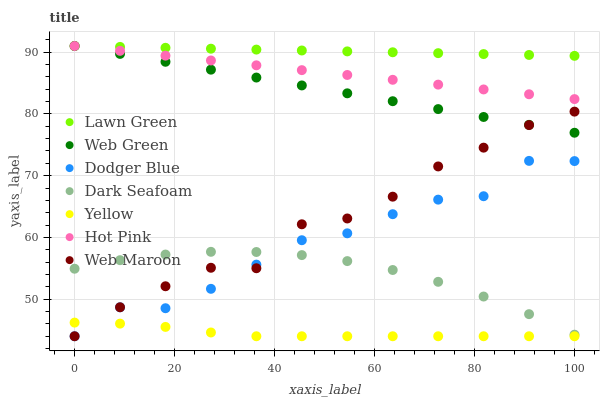Does Yellow have the minimum area under the curve?
Answer yes or no. Yes. Does Lawn Green have the maximum area under the curve?
Answer yes or no. Yes. Does Hot Pink have the minimum area under the curve?
Answer yes or no. No. Does Hot Pink have the maximum area under the curve?
Answer yes or no. No. Is Lawn Green the smoothest?
Answer yes or no. Yes. Is Dodger Blue the roughest?
Answer yes or no. Yes. Is Hot Pink the smoothest?
Answer yes or no. No. Is Hot Pink the roughest?
Answer yes or no. No. Does Web Maroon have the lowest value?
Answer yes or no. Yes. Does Hot Pink have the lowest value?
Answer yes or no. No. Does Web Green have the highest value?
Answer yes or no. Yes. Does Web Maroon have the highest value?
Answer yes or no. No. Is Yellow less than Web Green?
Answer yes or no. Yes. Is Hot Pink greater than Dodger Blue?
Answer yes or no. Yes. Does Dark Seafoam intersect Dodger Blue?
Answer yes or no. Yes. Is Dark Seafoam less than Dodger Blue?
Answer yes or no. No. Is Dark Seafoam greater than Dodger Blue?
Answer yes or no. No. Does Yellow intersect Web Green?
Answer yes or no. No. 